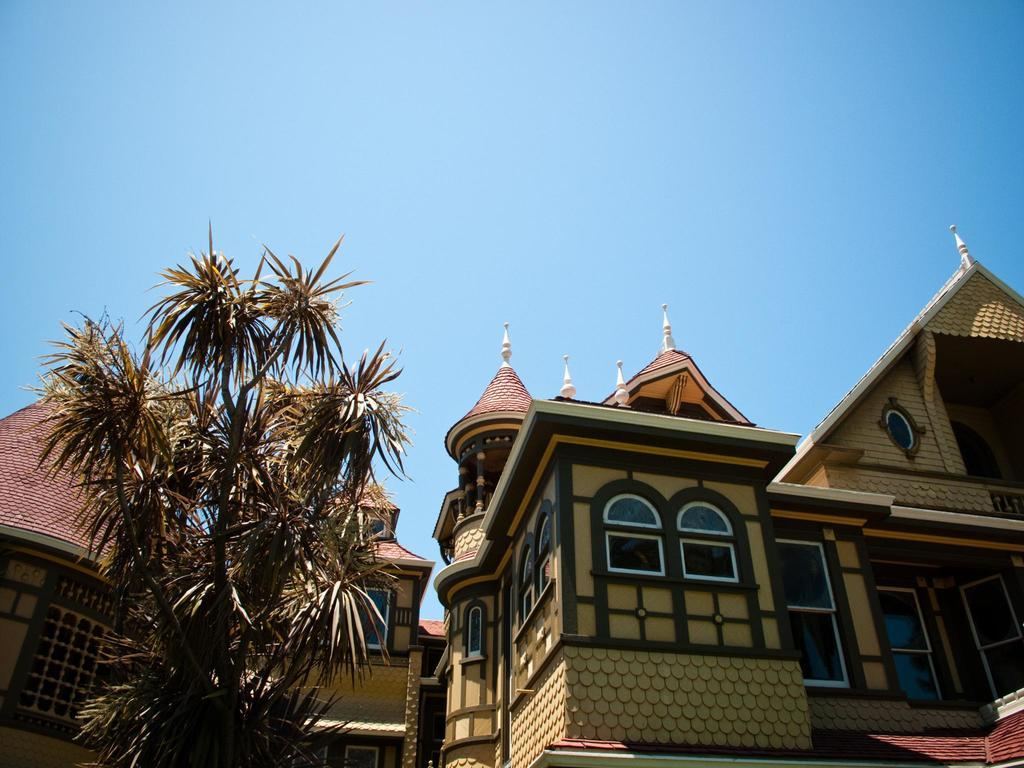What type of structures can be seen in the image? There are buildings in the image. What type of vegetation is present in the image? There is a tree in the image. What color is the sky in the image? The sky is blue in the image. Can you see a kitten playing with a baseball near the tree in the image? There is no kitten or baseball present in the image; it only features buildings, a tree, and a blue sky. 